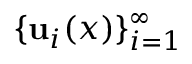<formula> <loc_0><loc_0><loc_500><loc_500>\{ { u } _ { i } ( x ) \} _ { i = 1 } ^ { \infty }</formula> 